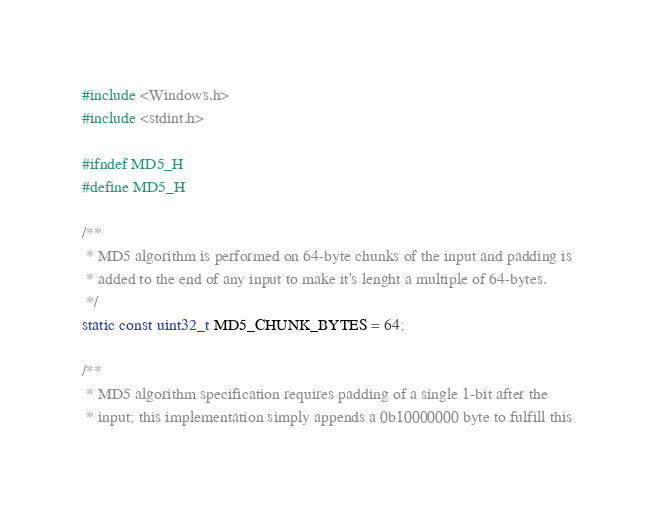Convert code to text. <code><loc_0><loc_0><loc_500><loc_500><_C_>#include <Windows.h>
#include <stdint.h>

#ifndef MD5_H
#define MD5_H

/**
 * MD5 algorithm is performed on 64-byte chunks of the input and padding is
 * added to the end of any input to make it's lenght a multiple of 64-bytes.
 */
static const uint32_t MD5_CHUNK_BYTES = 64;

/**
 * MD5 algorithm specification requires padding of a single 1-bit after the
 * input; this implementation simply appends a 0b10000000 byte to fulfill this</code> 